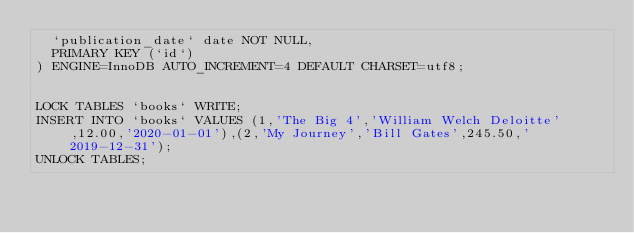<code> <loc_0><loc_0><loc_500><loc_500><_SQL_>  `publication_date` date NOT NULL,
  PRIMARY KEY (`id`)
) ENGINE=InnoDB AUTO_INCREMENT=4 DEFAULT CHARSET=utf8;


LOCK TABLES `books` WRITE;
INSERT INTO `books` VALUES (1,'The Big 4','William Welch Deloitte',12.00,'2020-01-01'),(2,'My Journey','Bill Gates',245.50,'2019-12-31');
UNLOCK TABLES;
</code> 